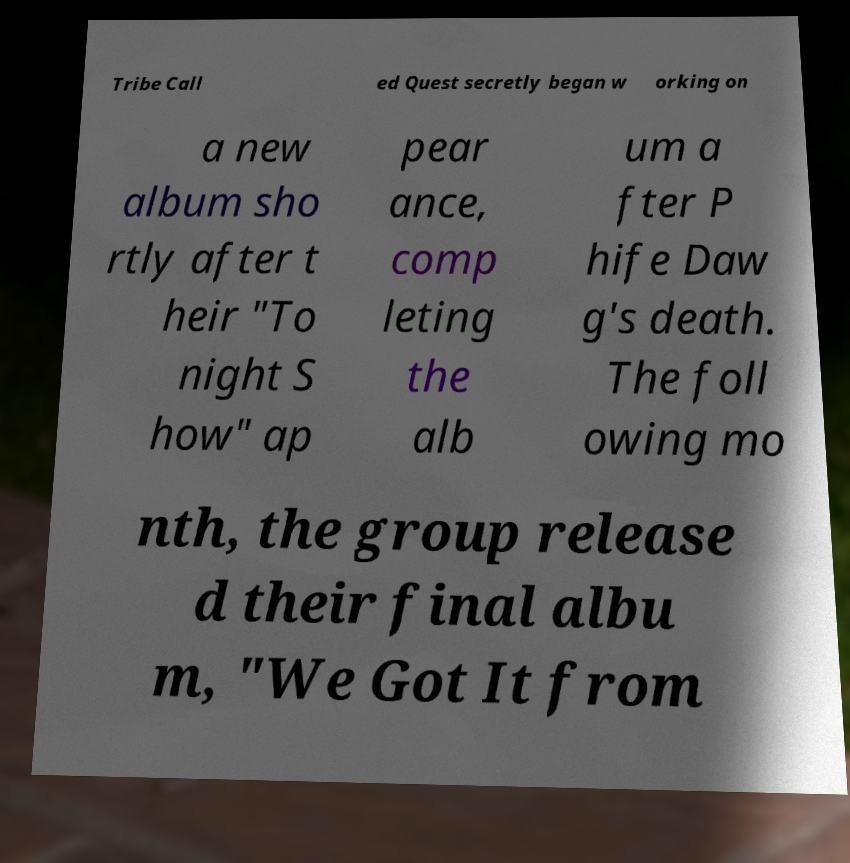There's text embedded in this image that I need extracted. Can you transcribe it verbatim? Tribe Call ed Quest secretly began w orking on a new album sho rtly after t heir "To night S how" ap pear ance, comp leting the alb um a fter P hife Daw g's death. The foll owing mo nth, the group release d their final albu m, "We Got It from 